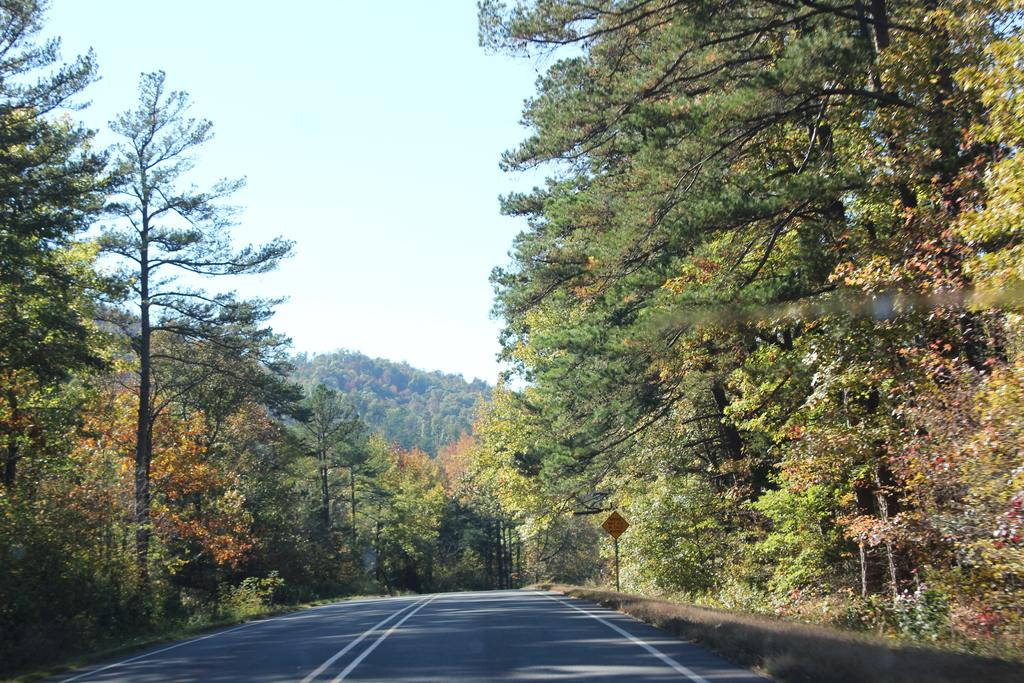What types of vegetation can be seen in the foreground of the picture? There are trees, plants, and grass in the foreground of the picture. What man-made object is present in the foreground of the picture? There is a sign board in the foreground of the picture. What type of pathway is visible in the foreground of the picture? There is a road in the foreground of the picture. What can be seen in the background of the picture? There are trees in the background of the picture. How is the weather in the image? The sky is sunny, indicating a clear and bright day. What is the weight of the crate in the image? There is no crate present in the image. What type of lipstick is the person wearing in the image? There are no people or lipstick visible in the image. 